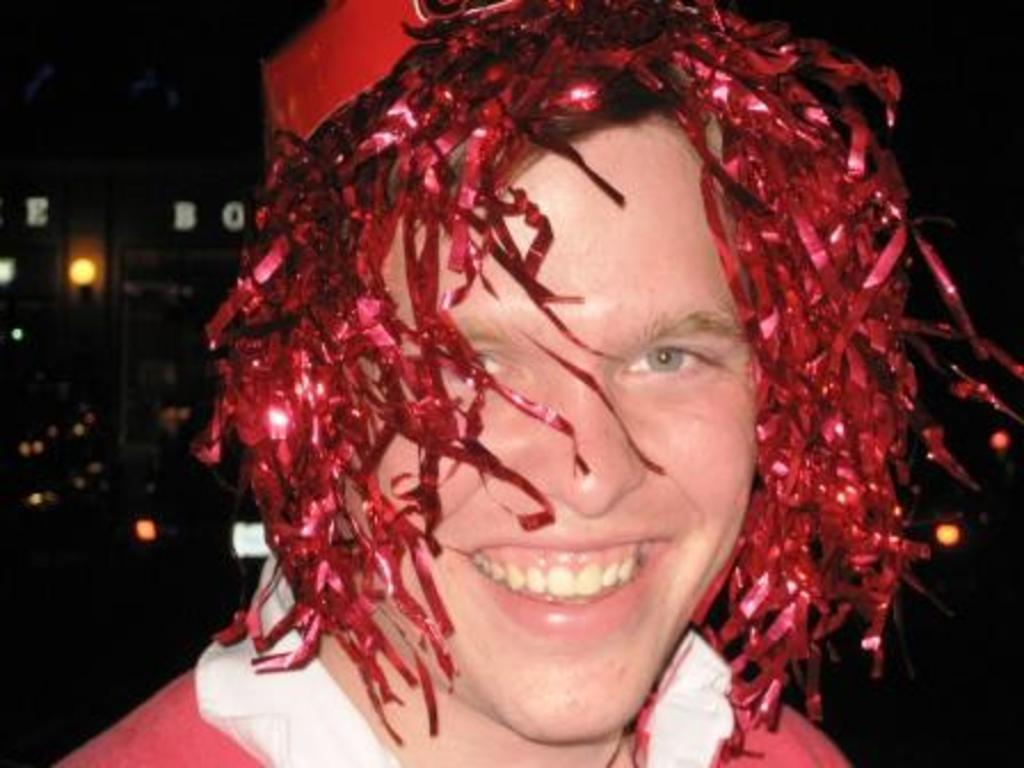What is the main subject of the image? There is a person in the image. What is the person wearing? The person is wearing a red and white color dress. What type of head-wear is the person wearing? The person is wearing head-wear. What can be seen in the background of the image? The background of the image is black. What else is visible in the image besides the person? There are lights visible in the image. What type of net is being used by the person in the image? There is no net present in the image; the person is wearing a dress and head-wear. What type of throne is the person sitting on in the image? There is no throne present in the image; the person is standing. 